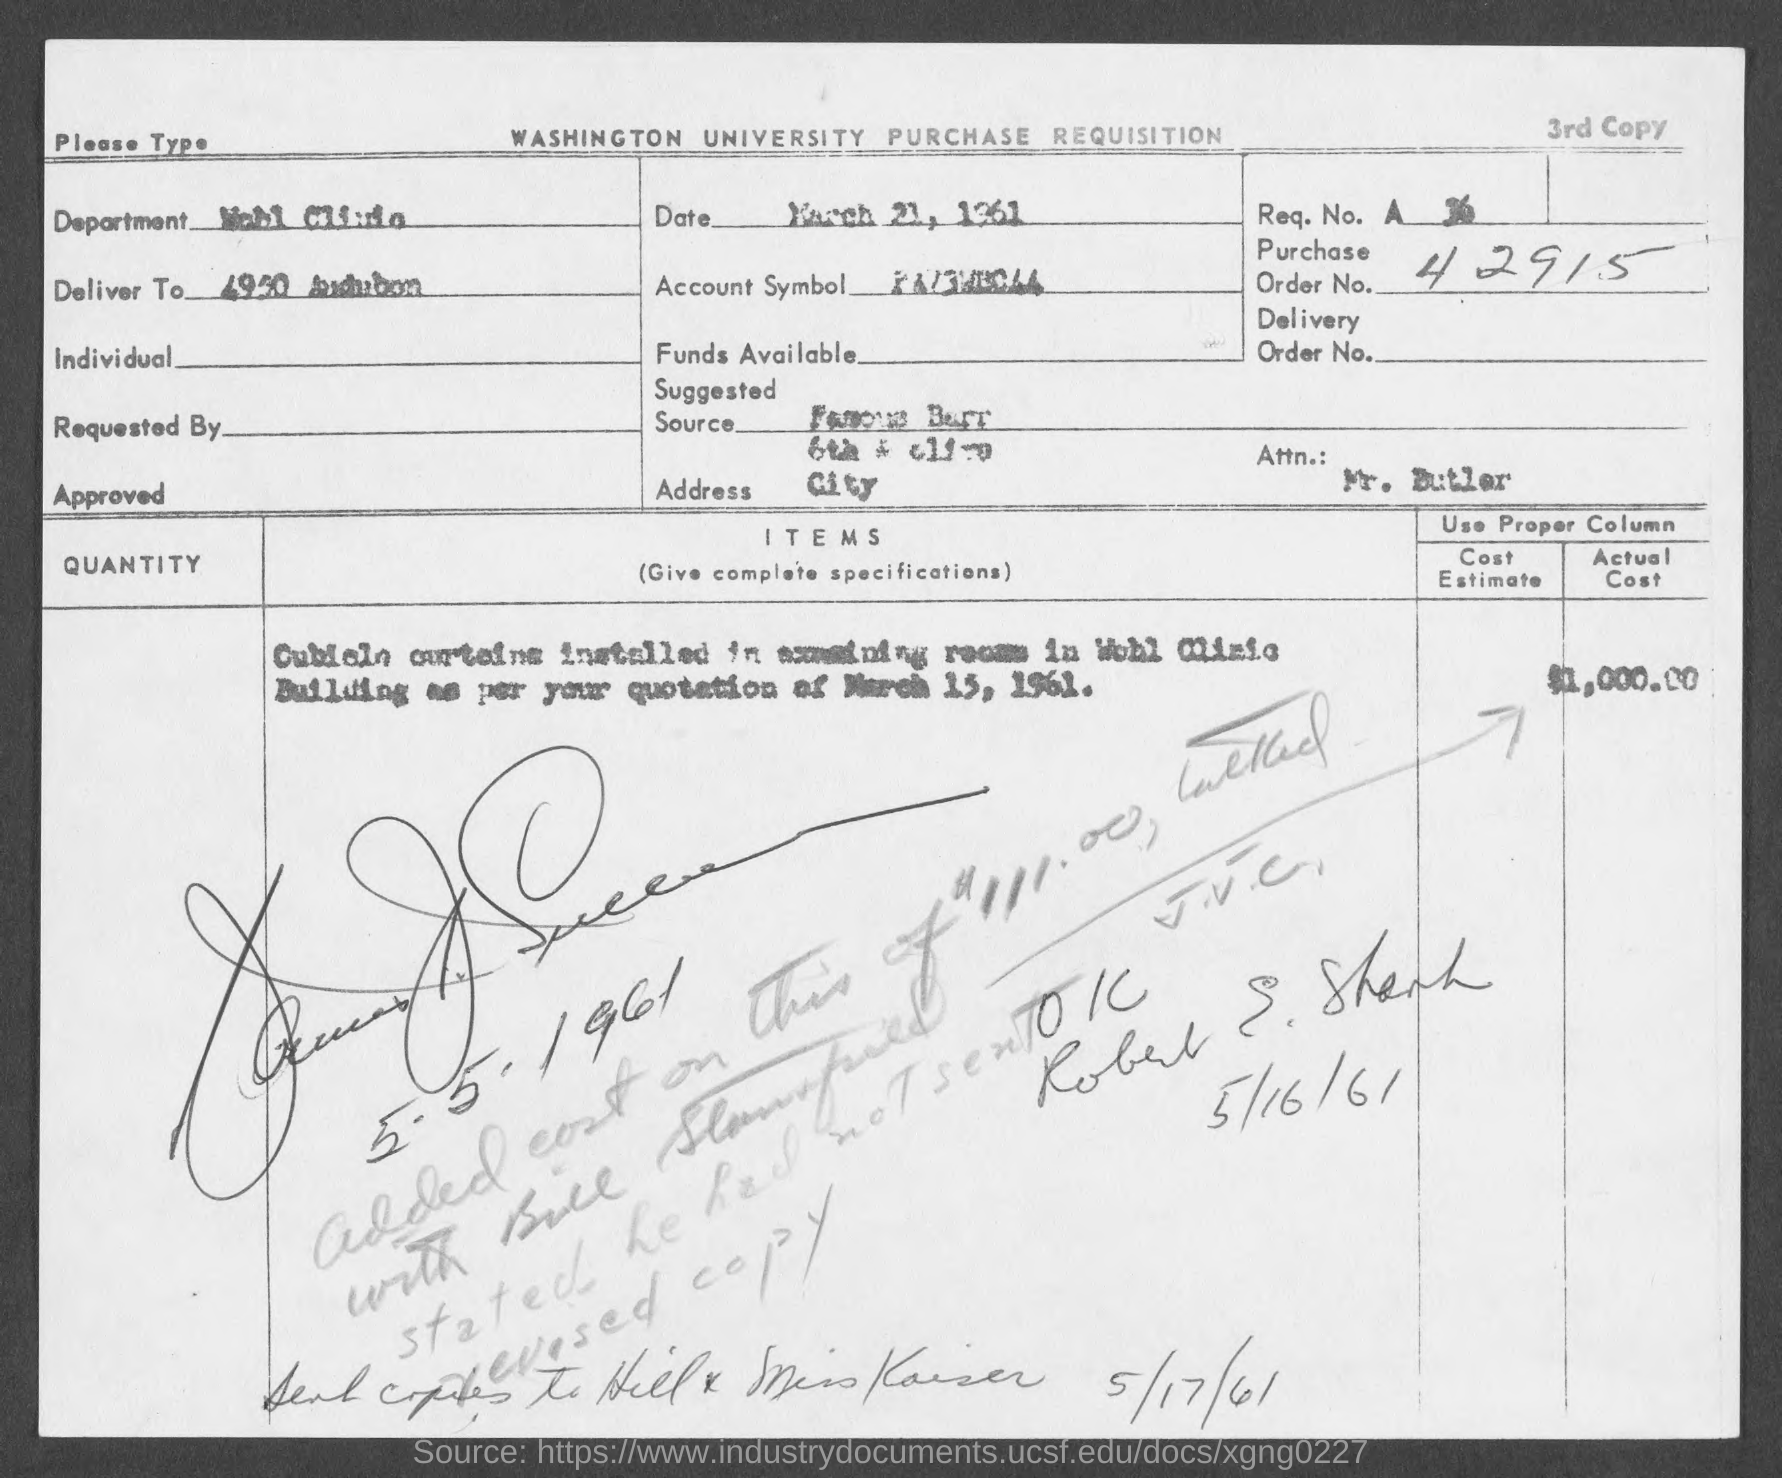Specify some key components in this picture. The purchase order number is 42915... 